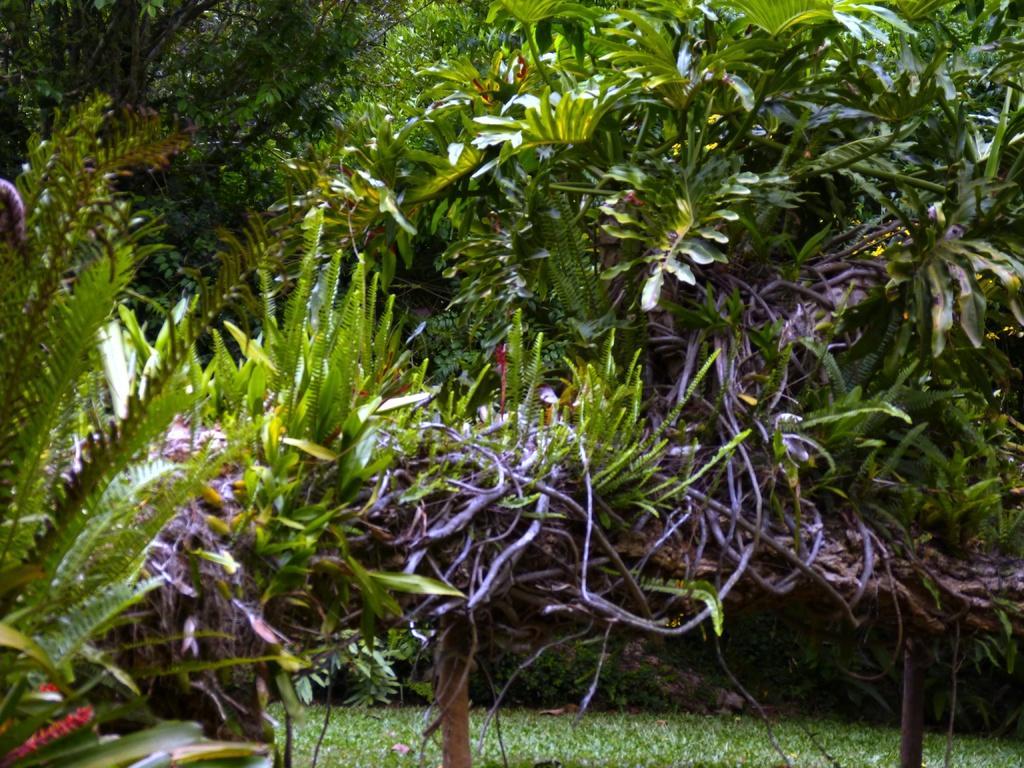In one or two sentences, can you explain what this image depicts? In the picture we can see a group of plants which are some blue in color and under it we can see a grass surface. 